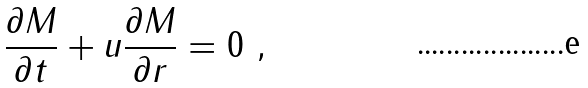Convert formula to latex. <formula><loc_0><loc_0><loc_500><loc_500>\frac { \partial M } { \partial t } + u \frac { \partial M } { \partial r } = 0 \ ,</formula> 